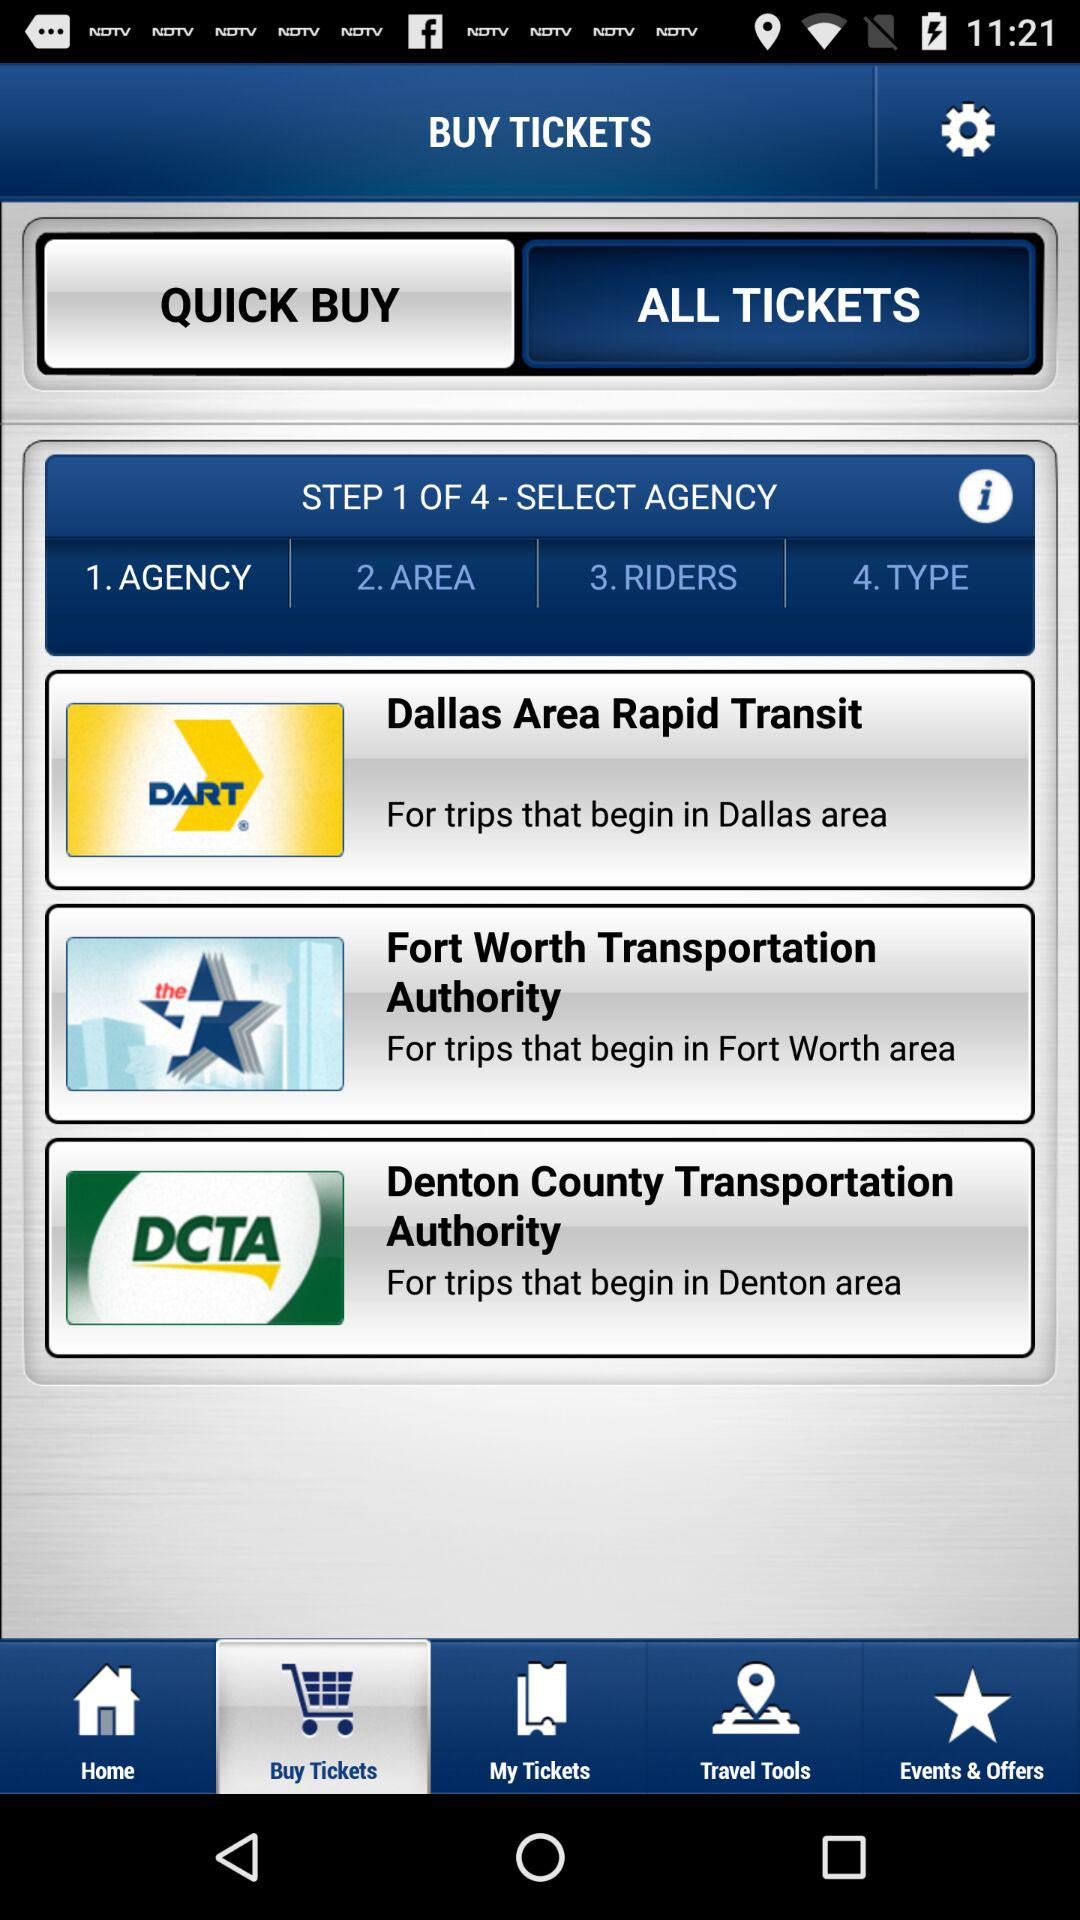How many agencies are available to select from? There are three transit agencies available to select from for purchasing tickets: Dallas Area Rapid Transit (DART), Fort Worth Transportation Authority, and Denton County Transportation Authority, each serving different geographical areas within the region. 